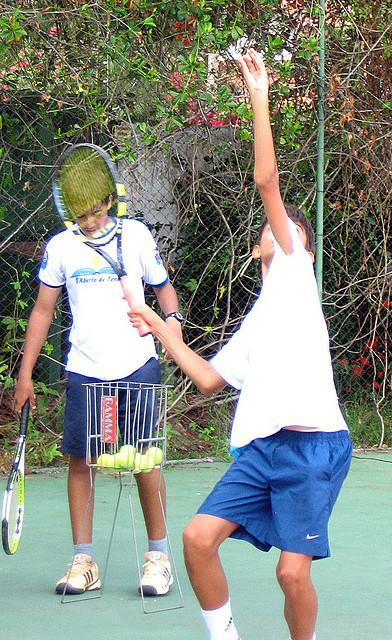What color are the interior nettings of the rackets used by the two men? yellow 